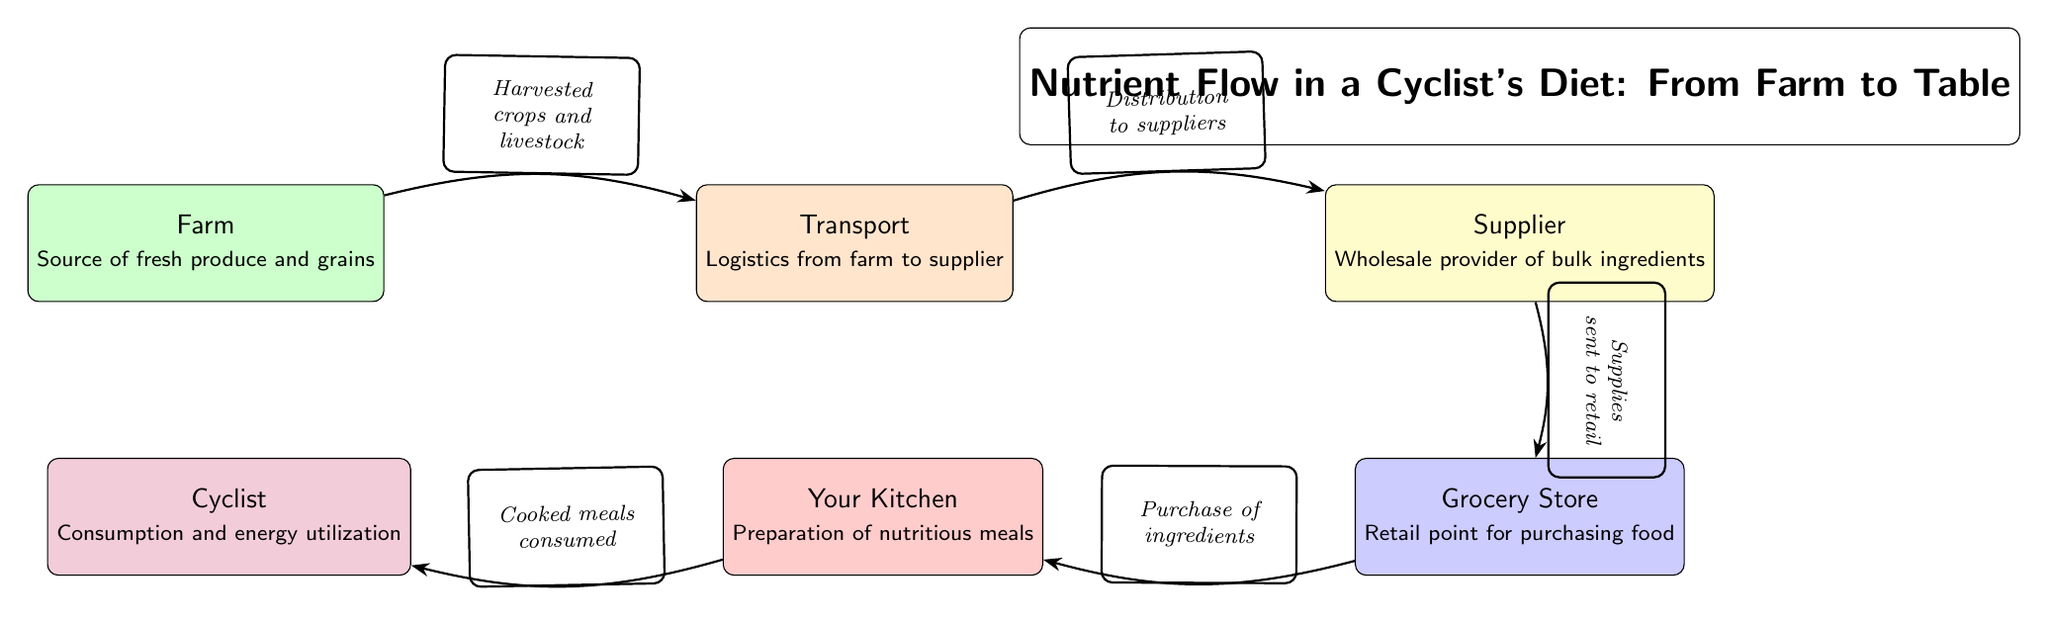What is the source of fresh produce and grains? The diagram indicates that the source is the "Farm," which is the starting point for the nutrient flow in a cyclist's diet.
Answer: Farm What color represents the grocery store? The grocery store is represented in blue, and this can be easily identified by looking at the color coding of the nodes in the diagram.
Answer: Blue How many nodes are there in the diagram? Counting all the distinct labeled sections in the diagram, there are six nodes: Farm, Transport, Supplier, Grocery Store, Your Kitchen, and Cyclist.
Answer: 6 What does the arrow from the supplier to the grocery store indicate? The arrow signifies the flow of supplies sent to the retail point of the grocery store, showing the direction of ingredient distribution.
Answer: Supplies sent to retail What meal preparation stage comes before the cyclist consumes food? The diagram shows that "Your Kitchen" is the stage where nutritious meals are prepared before consumption by the cyclist.
Answer: Your Kitchen What type of flow does the diagram illustrate? This diagram illustrates the flow of nutrients and ingredients through various stages, from the initial source to final consumption by a cyclist.
Answer: Nutrient flow What is transported from the farm to the supplier? The diagram specifies that "Harvested crops and livestock" are transported from the farm to the transport stage, indicating the goods moving along the chain.
Answer: Harvested crops and livestock What is the relationship between the grocery store and the kitchen? According to the diagram, the relationship is that ingredients purchased from the grocery store are taken to the kitchen for meal preparation.
Answer: Purchase of ingredients What is the final destination of the nutrient flow? The nutrient flow culminates at the "Cyclist," who represents the final consumer of the meals prepared earlier in the chain.
Answer: Cyclist 